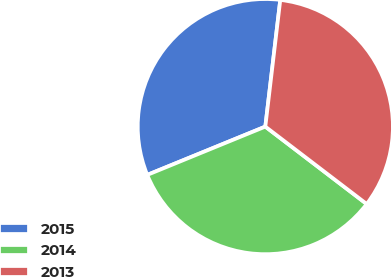Convert chart. <chart><loc_0><loc_0><loc_500><loc_500><pie_chart><fcel>2015<fcel>2014<fcel>2013<nl><fcel>33.05%<fcel>33.44%<fcel>33.51%<nl></chart> 